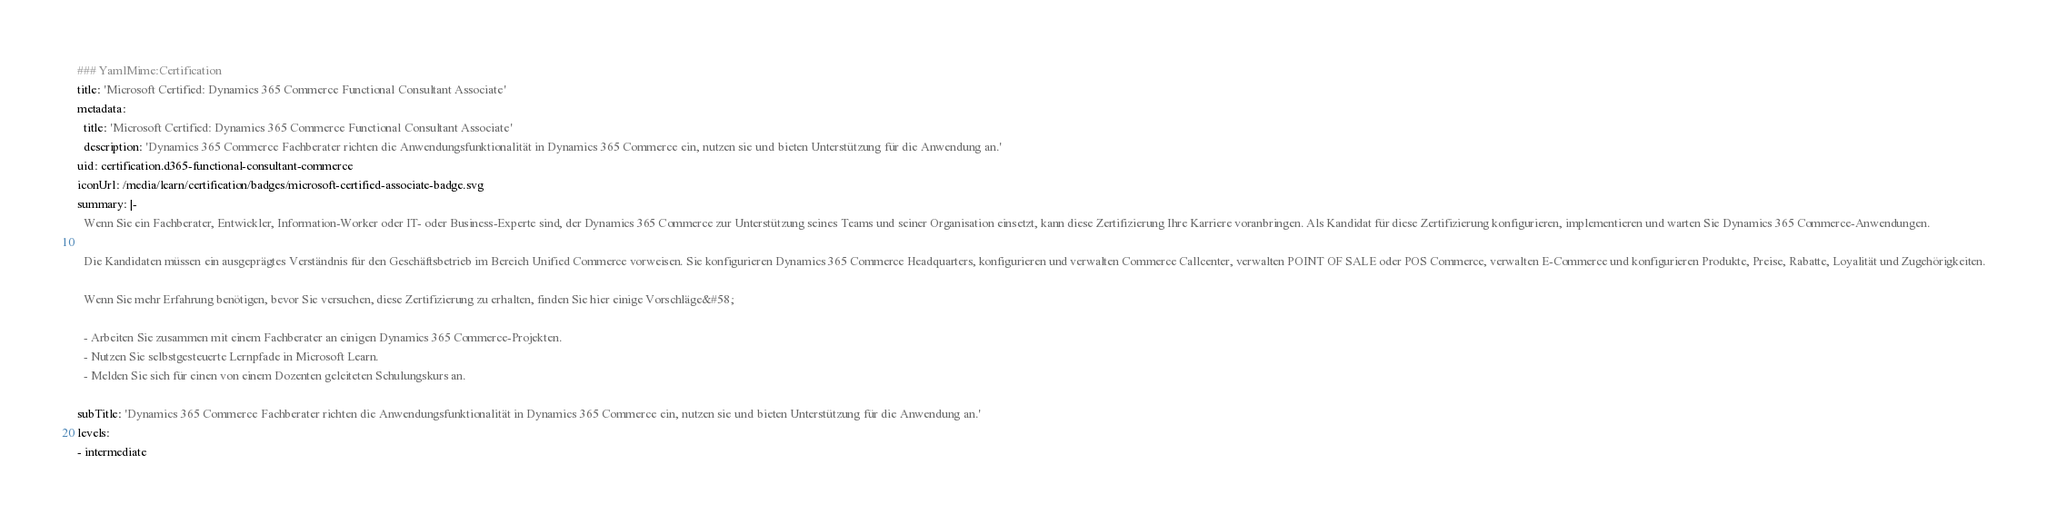<code> <loc_0><loc_0><loc_500><loc_500><_YAML_>### YamlMime:Certification
title: 'Microsoft Certified: Dynamics 365 Commerce Functional Consultant Associate'
metadata:
  title: 'Microsoft Certified: Dynamics 365 Commerce Functional Consultant Associate'
  description: 'Dynamics 365 Commerce Fachberater richten die Anwendungsfunktionalität in Dynamics 365 Commerce ein, nutzen sie und bieten Unterstützung für die Anwendung an.'
uid: certification.d365-functional-consultant-commerce
iconUrl: /media/learn/certification/badges/microsoft-certified-associate-badge.svg
summary: |-
  Wenn Sie ein Fachberater, Entwickler, Information-Worker oder IT- oder Business-Experte sind, der Dynamics 365 Commerce zur Unterstützung seines Teams und seiner Organisation einsetzt, kann diese Zertifizierung Ihre Karriere voranbringen. Als Kandidat für diese Zertifizierung konfigurieren, implementieren und warten Sie Dynamics 365 Commerce-Anwendungen.
  
  Die Kandidaten müssen ein ausgeprägtes Verständnis für den Geschäftsbetrieb im Bereich Unified Commerce vorweisen. Sie konfigurieren Dynamics 365 Commerce Headquarters, konfigurieren und verwalten Commerce Callcenter, verwalten POINT OF SALE oder POS Commerce, verwalten E-Commerce und konfigurieren Produkte, Preise, Rabatte, Loyalität und Zugehörigkeiten.
  
  Wenn Sie mehr Erfahrung benötigen, bevor Sie versuchen, diese Zertifizierung zu erhalten, finden Sie hier einige Vorschläge&#58;
  
  - Arbeiten Sie zusammen mit einem Fachberater an einigen Dynamics 365 Commerce-Projekten.
  - Nutzen Sie selbstgesteuerte Lernpfade in Microsoft Learn.
  - Melden Sie sich für einen von einem Dozenten geleiteten Schulungskurs an.
  
subTitle: 'Dynamics 365 Commerce Fachberater richten die Anwendungsfunktionalität in Dynamics 365 Commerce ein, nutzen sie und bieten Unterstützung für die Anwendung an.'
levels:
- intermediate</code> 